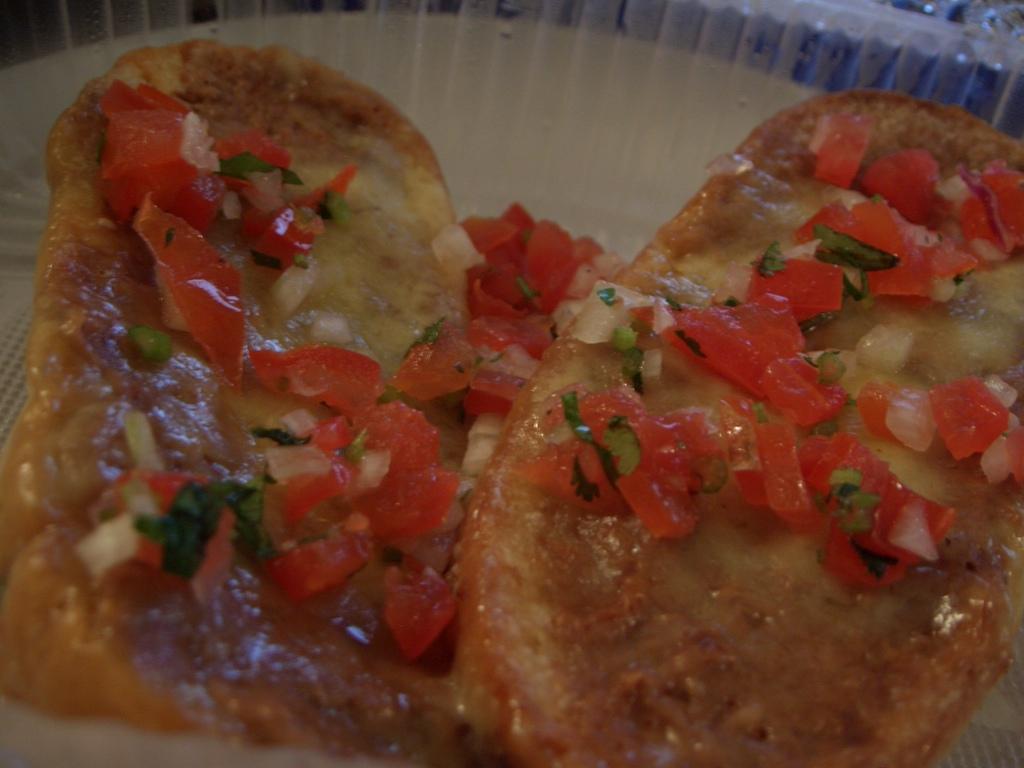Could you give a brief overview of what you see in this image? In this picture we can see some food here, there are some pieces of onion and tomato here. 